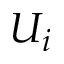Convert formula to latex. <formula><loc_0><loc_0><loc_500><loc_500>U _ { i }</formula> 